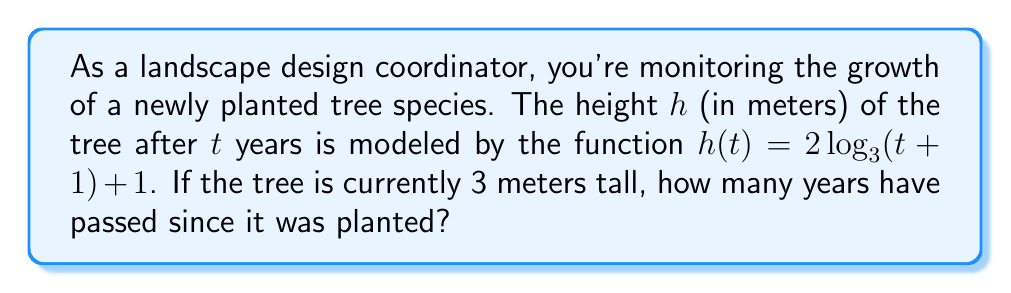Teach me how to tackle this problem. Let's approach this step-by-step:

1) We're given that the current height of the tree is 3 meters. We can express this using the function:

   $3 = 2 \log_3(t+1) + 1$

2) First, let's isolate the logarithmic term:

   $3 - 1 = 2 \log_3(t+1)$
   $2 = 2 \log_3(t+1)$

3) Now, divide both sides by 2:

   $1 = \log_3(t+1)$

4) To solve for $t$, we need to apply the inverse function (exponential) to both sides:

   $3^1 = 3^{\log_3(t+1)}$

5) The left side simplifies to 3, and on the right side, the base and logarithm cancel out:

   $3 = t+1$

6) Finally, solve for $t$:

   $t = 3 - 1 = 2$

Therefore, 2 years have passed since the tree was planted.
Answer: 2 years 